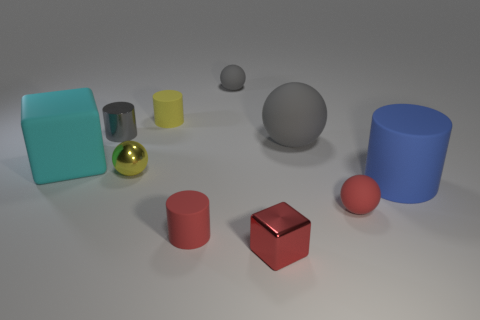Is there anything else that has the same material as the big cyan thing?
Your answer should be very brief. Yes. Do the large rubber sphere and the metallic cylinder have the same color?
Make the answer very short. Yes. What number of other things are there of the same size as the blue rubber cylinder?
Provide a short and direct response. 2. How many objects are tiny brown rubber spheres or rubber things to the right of the red rubber cylinder?
Your answer should be very brief. 4. Are there an equal number of cubes that are behind the small red ball and metallic cylinders?
Provide a short and direct response. Yes. The big gray thing that is made of the same material as the cyan object is what shape?
Make the answer very short. Sphere. Is there a tiny rubber thing of the same color as the small cube?
Your answer should be compact. Yes. What number of matte things are tiny red blocks or small gray objects?
Provide a succinct answer. 1. What number of big cyan matte objects are in front of the block that is on the right side of the big cyan thing?
Provide a short and direct response. 0. How many small gray cylinders have the same material as the tiny cube?
Your answer should be very brief. 1. 